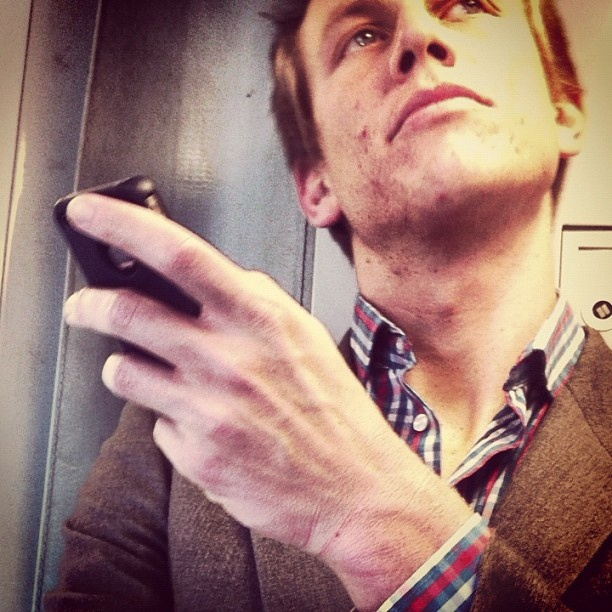Describe the objects in this image and their specific colors. I can see people in gray, lightpink, tan, brown, and maroon tones and cell phone in gray, black, purple, and brown tones in this image. 